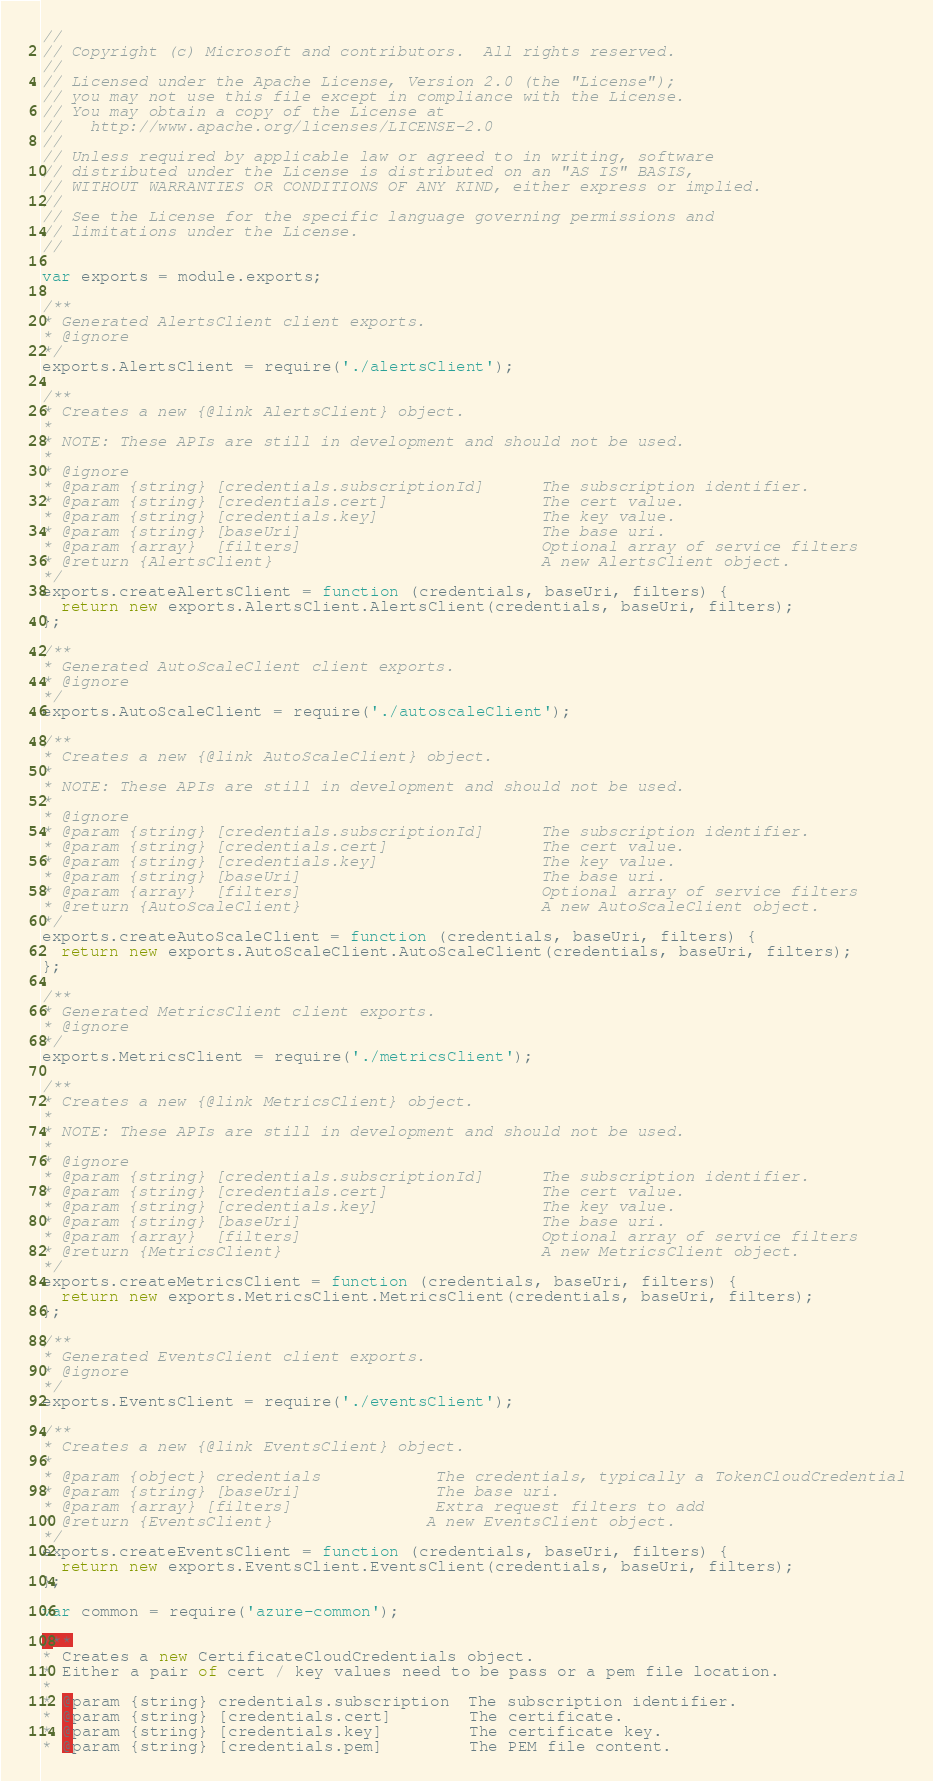Convert code to text. <code><loc_0><loc_0><loc_500><loc_500><_JavaScript_>//
// Copyright (c) Microsoft and contributors.  All rights reserved.
//
// Licensed under the Apache License, Version 2.0 (the "License");
// you may not use this file except in compliance with the License.
// You may obtain a copy of the License at
//   http://www.apache.org/licenses/LICENSE-2.0
//
// Unless required by applicable law or agreed to in writing, software
// distributed under the License is distributed on an "AS IS" BASIS,
// WITHOUT WARRANTIES OR CONDITIONS OF ANY KIND, either express or implied.
//
// See the License for the specific language governing permissions and
// limitations under the License.
//

var exports = module.exports;

/**
* Generated AlertsClient client exports.
* @ignore
*/
exports.AlertsClient = require('./alertsClient');

/**
* Creates a new {@link AlertsClient} object.
*
* NOTE: These APIs are still in development and should not be used.
*
* @ignore
* @param {string} [credentials.subscriptionId]      The subscription identifier.
* @param {string} [credentials.cert]                The cert value.
* @param {string} [credentials.key]                 The key value.
* @param {string} [baseUri]                         The base uri.
* @param {array}  [filters]                         Optional array of service filters
* @return {AlertsClient}                            A new AlertsClient object.
*/
exports.createAlertsClient = function (credentials, baseUri, filters) {
  return new exports.AlertsClient.AlertsClient(credentials, baseUri, filters);
};

/**
* Generated AutoScaleClient client exports.
* @ignore
*/
exports.AutoScaleClient = require('./autoscaleClient');

/**
* Creates a new {@link AutoScaleClient} object.
*
* NOTE: These APIs are still in development and should not be used.
*
* @ignore
* @param {string} [credentials.subscriptionId]      The subscription identifier.
* @param {string} [credentials.cert]                The cert value.
* @param {string} [credentials.key]                 The key value.
* @param {string} [baseUri]                         The base uri.
* @param {array}  [filters]                         Optional array of service filters
* @return {AutoScaleClient}                         A new AutoScaleClient object.
*/
exports.createAutoScaleClient = function (credentials, baseUri, filters) {
  return new exports.AutoScaleClient.AutoScaleClient(credentials, baseUri, filters);
};

/**
* Generated MetricsClient client exports.
* @ignore
*/
exports.MetricsClient = require('./metricsClient');

/**
* Creates a new {@link MetricsClient} object.
*
* NOTE: These APIs are still in development and should not be used.
*
* @ignore
* @param {string} [credentials.subscriptionId]      The subscription identifier.
* @param {string} [credentials.cert]                The cert value.
* @param {string} [credentials.key]                 The key value.
* @param {string} [baseUri]                         The base uri.
* @param {array}  [filters]                         Optional array of service filters
* @return {MetricsClient}                           A new MetricsClient object.
*/
exports.createMetricsClient = function (credentials, baseUri, filters) {
  return new exports.MetricsClient.MetricsClient(credentials, baseUri, filters);
};

/**
* Generated EventsClient client exports.
* @ignore
*/
exports.EventsClient = require('./eventsClient');

/**
* Creates a new {@link EventsClient} object.
*
* @param {object} credentials            The credentials, typically a TokenCloudCredential
* @param {string} [baseUri]              The base uri.
* @param {array} [filters]               Extra request filters to add
* @return {EventsClient}                A new EventsClient object.
*/
exports.createEventsClient = function (credentials, baseUri, filters) {
  return new exports.EventsClient.EventsClient(credentials, baseUri, filters);
};

var common = require('azure-common');

/**
* Creates a new CertificateCloudCredentials object.
* Either a pair of cert / key values need to be pass or a pem file location.
*
* @param {string} credentials.subscription  The subscription identifier.
* @param {string} [credentials.cert]        The certificate.
* @param {string} [credentials.key]         The certificate key.
* @param {string} [credentials.pem]         The PEM file content.</code> 